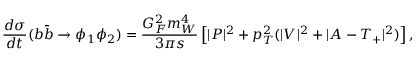<formula> <loc_0><loc_0><loc_500><loc_500>\frac { d \sigma } { d t } ( b \bar { b } \to \phi _ { 1 } \phi _ { 2 } ) = \frac { G _ { F } ^ { 2 } m _ { W } ^ { 4 } } { 3 \pi s } \left [ | P | ^ { 2 } + p _ { T } ^ { 2 } ( | V | ^ { 2 } + | A - T _ { + } | ^ { 2 } ) \right ] ,</formula> 